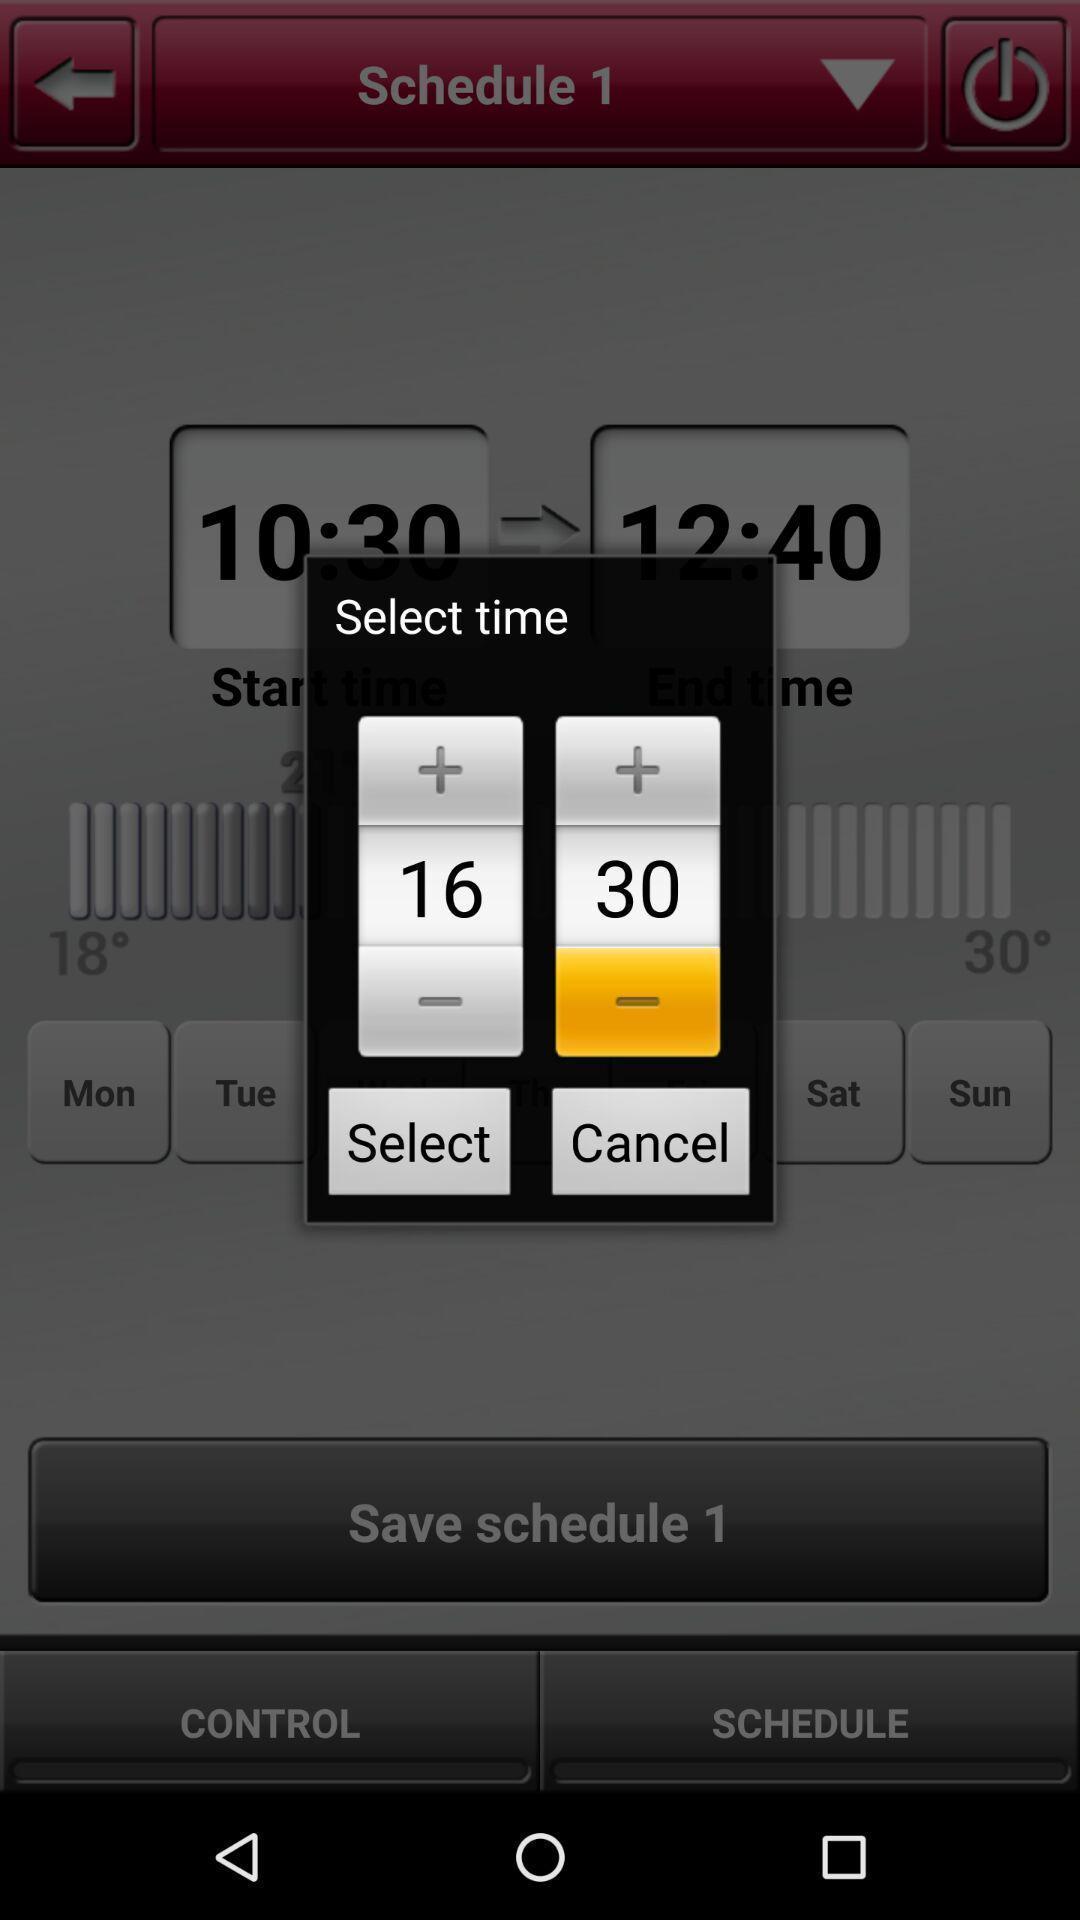Give me a narrative description of this picture. Pop-up showing select time option. 